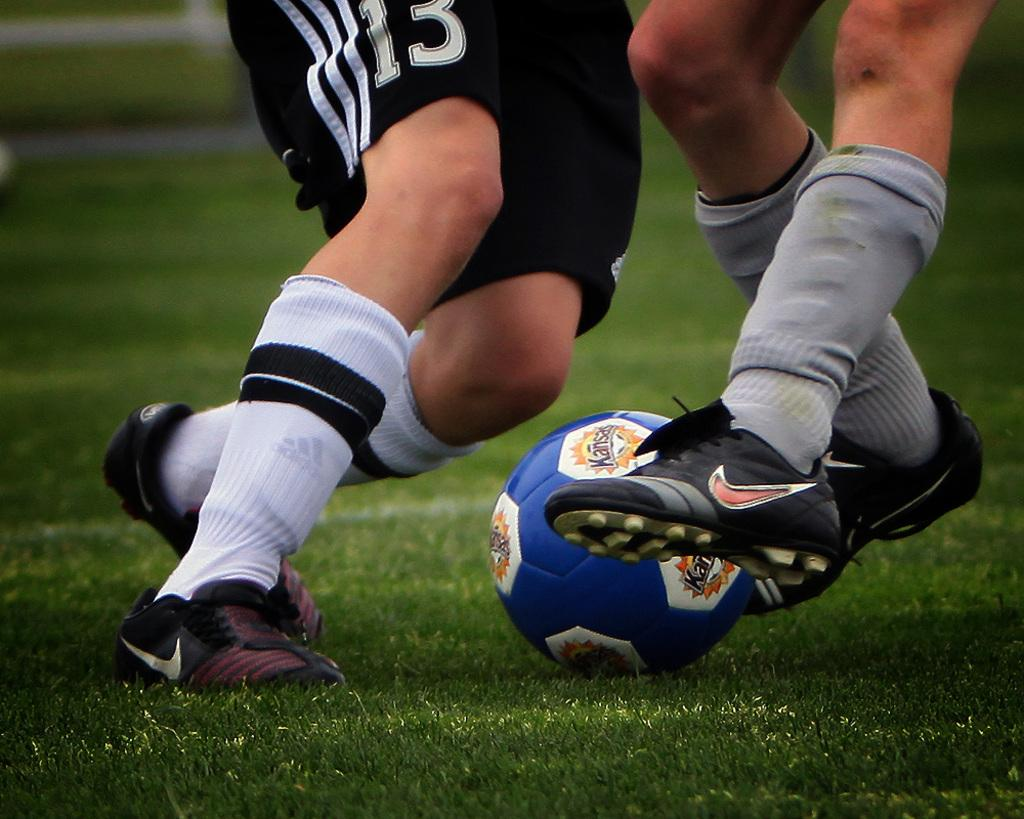How many persons can be seen in the image? There are legs of two persons in the image, suggesting that two persons are present. What type of clothing are the persons wearing on their lower bodies? The persons are wearing shorts in the image. What type of footwear are the persons wearing? The persons are wearing shoes in the image. What can be seen on their feet besides shoes? The persons are also wearing socks in the image. What object is visible in the image that might be used for playing? There is a ball in the image. What type of surface is visible in the image? There is grass visible in the image. What type of weather is indicated by the presence of sleet in the image? There is no mention of sleet in the image; it only shows grass and a ball. How does the coastline appear in the image? There is no coastline present in the image; it features grass, a ball, and two persons wearing shorts, socks, and shoes. 